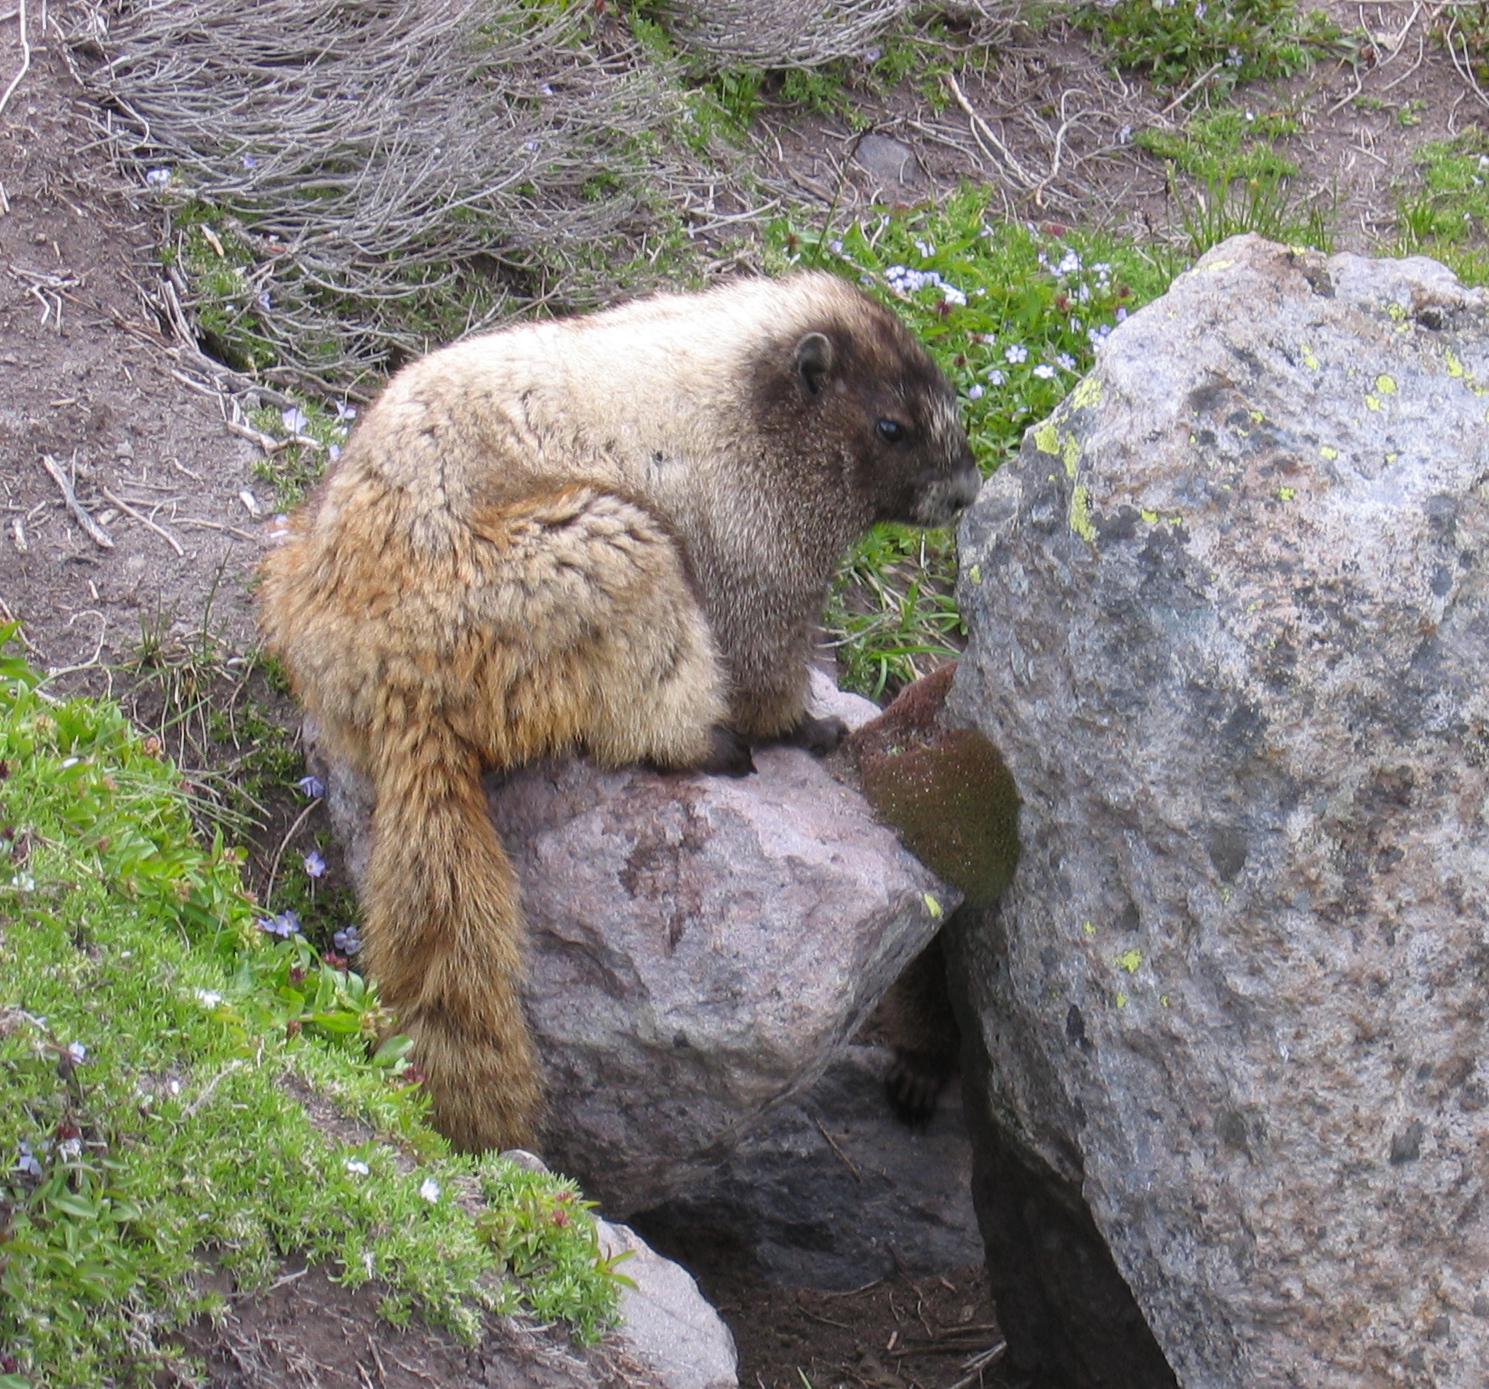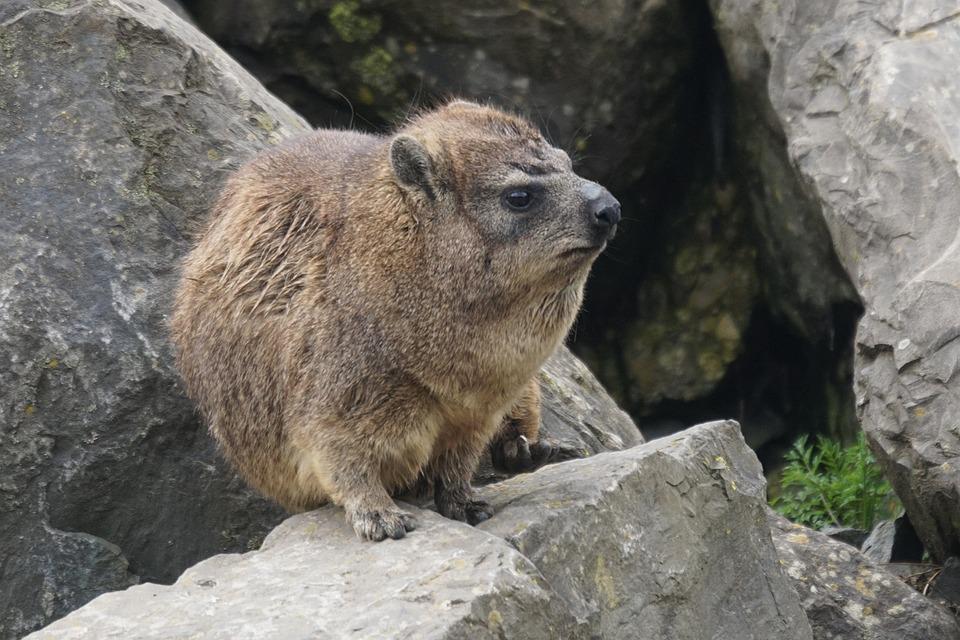The first image is the image on the left, the second image is the image on the right. Considering the images on both sides, is "The animal in the image on the right is on some form of vegetation." valid? Answer yes or no. No. 